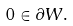<formula> <loc_0><loc_0><loc_500><loc_500>0 \in \partial W .</formula> 